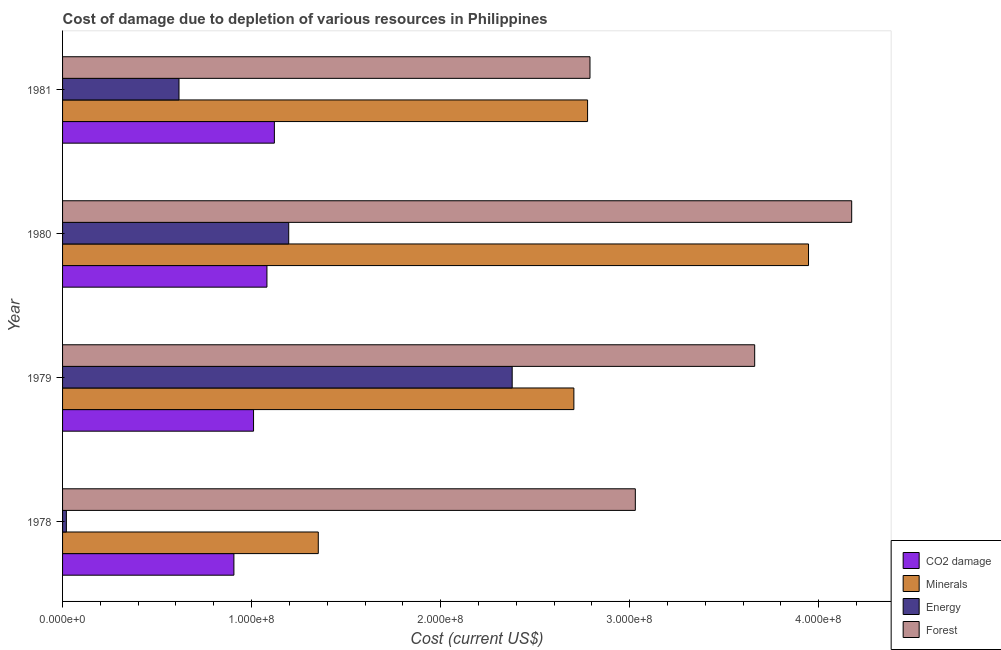How many bars are there on the 3rd tick from the top?
Your answer should be very brief. 4. How many bars are there on the 3rd tick from the bottom?
Provide a succinct answer. 4. What is the label of the 4th group of bars from the top?
Your answer should be compact. 1978. What is the cost of damage due to depletion of minerals in 1981?
Give a very brief answer. 2.78e+08. Across all years, what is the maximum cost of damage due to depletion of coal?
Offer a very short reply. 1.12e+08. Across all years, what is the minimum cost of damage due to depletion of minerals?
Make the answer very short. 1.35e+08. In which year was the cost of damage due to depletion of minerals minimum?
Your response must be concise. 1978. What is the total cost of damage due to depletion of energy in the graph?
Keep it short and to the point. 4.21e+08. What is the difference between the cost of damage due to depletion of minerals in 1980 and that in 1981?
Give a very brief answer. 1.17e+08. What is the difference between the cost of damage due to depletion of coal in 1981 and the cost of damage due to depletion of minerals in 1980?
Provide a short and direct response. -2.83e+08. What is the average cost of damage due to depletion of minerals per year?
Make the answer very short. 2.70e+08. In the year 1978, what is the difference between the cost of damage due to depletion of coal and cost of damage due to depletion of minerals?
Your answer should be very brief. -4.46e+07. What is the ratio of the cost of damage due to depletion of coal in 1979 to that in 1980?
Keep it short and to the point. 0.93. What is the difference between the highest and the second highest cost of damage due to depletion of coal?
Ensure brevity in your answer.  3.93e+06. What is the difference between the highest and the lowest cost of damage due to depletion of forests?
Your answer should be very brief. 1.38e+08. In how many years, is the cost of damage due to depletion of energy greater than the average cost of damage due to depletion of energy taken over all years?
Your response must be concise. 2. What does the 1st bar from the top in 1980 represents?
Make the answer very short. Forest. What does the 1st bar from the bottom in 1979 represents?
Make the answer very short. CO2 damage. Is it the case that in every year, the sum of the cost of damage due to depletion of coal and cost of damage due to depletion of minerals is greater than the cost of damage due to depletion of energy?
Ensure brevity in your answer.  Yes. How many bars are there?
Provide a succinct answer. 16. Are all the bars in the graph horizontal?
Offer a terse response. Yes. Does the graph contain any zero values?
Offer a very short reply. No. How many legend labels are there?
Your answer should be compact. 4. How are the legend labels stacked?
Provide a short and direct response. Vertical. What is the title of the graph?
Provide a succinct answer. Cost of damage due to depletion of various resources in Philippines . What is the label or title of the X-axis?
Your answer should be very brief. Cost (current US$). What is the Cost (current US$) in CO2 damage in 1978?
Your answer should be very brief. 9.06e+07. What is the Cost (current US$) of Minerals in 1978?
Ensure brevity in your answer.  1.35e+08. What is the Cost (current US$) of Energy in 1978?
Provide a short and direct response. 2.02e+06. What is the Cost (current US$) in Forest in 1978?
Provide a succinct answer. 3.03e+08. What is the Cost (current US$) in CO2 damage in 1979?
Make the answer very short. 1.01e+08. What is the Cost (current US$) of Minerals in 1979?
Your answer should be very brief. 2.70e+08. What is the Cost (current US$) of Energy in 1979?
Provide a short and direct response. 2.38e+08. What is the Cost (current US$) of Forest in 1979?
Your response must be concise. 3.66e+08. What is the Cost (current US$) in CO2 damage in 1980?
Ensure brevity in your answer.  1.08e+08. What is the Cost (current US$) in Minerals in 1980?
Your answer should be very brief. 3.95e+08. What is the Cost (current US$) of Energy in 1980?
Offer a terse response. 1.20e+08. What is the Cost (current US$) in Forest in 1980?
Keep it short and to the point. 4.17e+08. What is the Cost (current US$) in CO2 damage in 1981?
Your answer should be very brief. 1.12e+08. What is the Cost (current US$) of Minerals in 1981?
Your response must be concise. 2.78e+08. What is the Cost (current US$) in Energy in 1981?
Provide a short and direct response. 6.16e+07. What is the Cost (current US$) in Forest in 1981?
Ensure brevity in your answer.  2.79e+08. Across all years, what is the maximum Cost (current US$) of CO2 damage?
Give a very brief answer. 1.12e+08. Across all years, what is the maximum Cost (current US$) in Minerals?
Your answer should be very brief. 3.95e+08. Across all years, what is the maximum Cost (current US$) of Energy?
Keep it short and to the point. 2.38e+08. Across all years, what is the maximum Cost (current US$) of Forest?
Ensure brevity in your answer.  4.17e+08. Across all years, what is the minimum Cost (current US$) in CO2 damage?
Offer a very short reply. 9.06e+07. Across all years, what is the minimum Cost (current US$) in Minerals?
Make the answer very short. 1.35e+08. Across all years, what is the minimum Cost (current US$) in Energy?
Make the answer very short. 2.02e+06. Across all years, what is the minimum Cost (current US$) of Forest?
Ensure brevity in your answer.  2.79e+08. What is the total Cost (current US$) of CO2 damage in the graph?
Offer a very short reply. 4.12e+08. What is the total Cost (current US$) in Minerals in the graph?
Provide a succinct answer. 1.08e+09. What is the total Cost (current US$) in Energy in the graph?
Make the answer very short. 4.21e+08. What is the total Cost (current US$) in Forest in the graph?
Give a very brief answer. 1.37e+09. What is the difference between the Cost (current US$) of CO2 damage in 1978 and that in 1979?
Your answer should be very brief. -1.04e+07. What is the difference between the Cost (current US$) of Minerals in 1978 and that in 1979?
Your answer should be very brief. -1.35e+08. What is the difference between the Cost (current US$) of Energy in 1978 and that in 1979?
Offer a very short reply. -2.36e+08. What is the difference between the Cost (current US$) in Forest in 1978 and that in 1979?
Offer a terse response. -6.31e+07. What is the difference between the Cost (current US$) in CO2 damage in 1978 and that in 1980?
Offer a terse response. -1.75e+07. What is the difference between the Cost (current US$) in Minerals in 1978 and that in 1980?
Offer a terse response. -2.59e+08. What is the difference between the Cost (current US$) in Energy in 1978 and that in 1980?
Keep it short and to the point. -1.18e+08. What is the difference between the Cost (current US$) of Forest in 1978 and that in 1980?
Keep it short and to the point. -1.14e+08. What is the difference between the Cost (current US$) in CO2 damage in 1978 and that in 1981?
Your response must be concise. -2.14e+07. What is the difference between the Cost (current US$) of Minerals in 1978 and that in 1981?
Your response must be concise. -1.42e+08. What is the difference between the Cost (current US$) in Energy in 1978 and that in 1981?
Give a very brief answer. -5.96e+07. What is the difference between the Cost (current US$) of Forest in 1978 and that in 1981?
Your answer should be compact. 2.40e+07. What is the difference between the Cost (current US$) of CO2 damage in 1979 and that in 1980?
Offer a terse response. -7.08e+06. What is the difference between the Cost (current US$) in Minerals in 1979 and that in 1980?
Make the answer very short. -1.24e+08. What is the difference between the Cost (current US$) of Energy in 1979 and that in 1980?
Provide a succinct answer. 1.18e+08. What is the difference between the Cost (current US$) of Forest in 1979 and that in 1980?
Offer a terse response. -5.13e+07. What is the difference between the Cost (current US$) in CO2 damage in 1979 and that in 1981?
Give a very brief answer. -1.10e+07. What is the difference between the Cost (current US$) in Minerals in 1979 and that in 1981?
Ensure brevity in your answer.  -7.25e+06. What is the difference between the Cost (current US$) of Energy in 1979 and that in 1981?
Your answer should be compact. 1.76e+08. What is the difference between the Cost (current US$) in Forest in 1979 and that in 1981?
Offer a terse response. 8.71e+07. What is the difference between the Cost (current US$) in CO2 damage in 1980 and that in 1981?
Keep it short and to the point. -3.93e+06. What is the difference between the Cost (current US$) in Minerals in 1980 and that in 1981?
Give a very brief answer. 1.17e+08. What is the difference between the Cost (current US$) in Energy in 1980 and that in 1981?
Your answer should be very brief. 5.80e+07. What is the difference between the Cost (current US$) of Forest in 1980 and that in 1981?
Provide a succinct answer. 1.38e+08. What is the difference between the Cost (current US$) of CO2 damage in 1978 and the Cost (current US$) of Minerals in 1979?
Make the answer very short. -1.80e+08. What is the difference between the Cost (current US$) in CO2 damage in 1978 and the Cost (current US$) in Energy in 1979?
Keep it short and to the point. -1.47e+08. What is the difference between the Cost (current US$) of CO2 damage in 1978 and the Cost (current US$) of Forest in 1979?
Give a very brief answer. -2.75e+08. What is the difference between the Cost (current US$) in Minerals in 1978 and the Cost (current US$) in Energy in 1979?
Your answer should be very brief. -1.03e+08. What is the difference between the Cost (current US$) of Minerals in 1978 and the Cost (current US$) of Forest in 1979?
Provide a succinct answer. -2.31e+08. What is the difference between the Cost (current US$) in Energy in 1978 and the Cost (current US$) in Forest in 1979?
Make the answer very short. -3.64e+08. What is the difference between the Cost (current US$) in CO2 damage in 1978 and the Cost (current US$) in Minerals in 1980?
Make the answer very short. -3.04e+08. What is the difference between the Cost (current US$) in CO2 damage in 1978 and the Cost (current US$) in Energy in 1980?
Provide a short and direct response. -2.90e+07. What is the difference between the Cost (current US$) of CO2 damage in 1978 and the Cost (current US$) of Forest in 1980?
Give a very brief answer. -3.27e+08. What is the difference between the Cost (current US$) of Minerals in 1978 and the Cost (current US$) of Energy in 1980?
Give a very brief answer. 1.56e+07. What is the difference between the Cost (current US$) in Minerals in 1978 and the Cost (current US$) in Forest in 1980?
Provide a succinct answer. -2.82e+08. What is the difference between the Cost (current US$) of Energy in 1978 and the Cost (current US$) of Forest in 1980?
Your answer should be compact. -4.15e+08. What is the difference between the Cost (current US$) in CO2 damage in 1978 and the Cost (current US$) in Minerals in 1981?
Your answer should be compact. -1.87e+08. What is the difference between the Cost (current US$) of CO2 damage in 1978 and the Cost (current US$) of Energy in 1981?
Ensure brevity in your answer.  2.90e+07. What is the difference between the Cost (current US$) in CO2 damage in 1978 and the Cost (current US$) in Forest in 1981?
Offer a terse response. -1.88e+08. What is the difference between the Cost (current US$) in Minerals in 1978 and the Cost (current US$) in Energy in 1981?
Make the answer very short. 7.37e+07. What is the difference between the Cost (current US$) of Minerals in 1978 and the Cost (current US$) of Forest in 1981?
Provide a short and direct response. -1.44e+08. What is the difference between the Cost (current US$) of Energy in 1978 and the Cost (current US$) of Forest in 1981?
Provide a succinct answer. -2.77e+08. What is the difference between the Cost (current US$) in CO2 damage in 1979 and the Cost (current US$) in Minerals in 1980?
Offer a terse response. -2.94e+08. What is the difference between the Cost (current US$) of CO2 damage in 1979 and the Cost (current US$) of Energy in 1980?
Your answer should be compact. -1.86e+07. What is the difference between the Cost (current US$) of CO2 damage in 1979 and the Cost (current US$) of Forest in 1980?
Keep it short and to the point. -3.16e+08. What is the difference between the Cost (current US$) in Minerals in 1979 and the Cost (current US$) in Energy in 1980?
Make the answer very short. 1.51e+08. What is the difference between the Cost (current US$) of Minerals in 1979 and the Cost (current US$) of Forest in 1980?
Offer a terse response. -1.47e+08. What is the difference between the Cost (current US$) in Energy in 1979 and the Cost (current US$) in Forest in 1980?
Your answer should be very brief. -1.80e+08. What is the difference between the Cost (current US$) in CO2 damage in 1979 and the Cost (current US$) in Minerals in 1981?
Provide a succinct answer. -1.77e+08. What is the difference between the Cost (current US$) in CO2 damage in 1979 and the Cost (current US$) in Energy in 1981?
Offer a terse response. 3.94e+07. What is the difference between the Cost (current US$) in CO2 damage in 1979 and the Cost (current US$) in Forest in 1981?
Provide a succinct answer. -1.78e+08. What is the difference between the Cost (current US$) of Minerals in 1979 and the Cost (current US$) of Energy in 1981?
Your answer should be very brief. 2.09e+08. What is the difference between the Cost (current US$) of Minerals in 1979 and the Cost (current US$) of Forest in 1981?
Your answer should be very brief. -8.52e+06. What is the difference between the Cost (current US$) in Energy in 1979 and the Cost (current US$) in Forest in 1981?
Make the answer very short. -4.12e+07. What is the difference between the Cost (current US$) of CO2 damage in 1980 and the Cost (current US$) of Minerals in 1981?
Provide a short and direct response. -1.70e+08. What is the difference between the Cost (current US$) in CO2 damage in 1980 and the Cost (current US$) in Energy in 1981?
Offer a very short reply. 4.65e+07. What is the difference between the Cost (current US$) of CO2 damage in 1980 and the Cost (current US$) of Forest in 1981?
Give a very brief answer. -1.71e+08. What is the difference between the Cost (current US$) of Minerals in 1980 and the Cost (current US$) of Energy in 1981?
Your answer should be compact. 3.33e+08. What is the difference between the Cost (current US$) in Minerals in 1980 and the Cost (current US$) in Forest in 1981?
Offer a very short reply. 1.16e+08. What is the difference between the Cost (current US$) of Energy in 1980 and the Cost (current US$) of Forest in 1981?
Ensure brevity in your answer.  -1.59e+08. What is the average Cost (current US$) of CO2 damage per year?
Ensure brevity in your answer.  1.03e+08. What is the average Cost (current US$) of Minerals per year?
Your answer should be very brief. 2.70e+08. What is the average Cost (current US$) in Energy per year?
Give a very brief answer. 1.05e+08. What is the average Cost (current US$) in Forest per year?
Your answer should be very brief. 3.41e+08. In the year 1978, what is the difference between the Cost (current US$) in CO2 damage and Cost (current US$) in Minerals?
Make the answer very short. -4.46e+07. In the year 1978, what is the difference between the Cost (current US$) of CO2 damage and Cost (current US$) of Energy?
Provide a short and direct response. 8.86e+07. In the year 1978, what is the difference between the Cost (current US$) of CO2 damage and Cost (current US$) of Forest?
Offer a terse response. -2.12e+08. In the year 1978, what is the difference between the Cost (current US$) of Minerals and Cost (current US$) of Energy?
Give a very brief answer. 1.33e+08. In the year 1978, what is the difference between the Cost (current US$) of Minerals and Cost (current US$) of Forest?
Ensure brevity in your answer.  -1.68e+08. In the year 1978, what is the difference between the Cost (current US$) in Energy and Cost (current US$) in Forest?
Ensure brevity in your answer.  -3.01e+08. In the year 1979, what is the difference between the Cost (current US$) of CO2 damage and Cost (current US$) of Minerals?
Your answer should be very brief. -1.69e+08. In the year 1979, what is the difference between the Cost (current US$) of CO2 damage and Cost (current US$) of Energy?
Ensure brevity in your answer.  -1.37e+08. In the year 1979, what is the difference between the Cost (current US$) of CO2 damage and Cost (current US$) of Forest?
Make the answer very short. -2.65e+08. In the year 1979, what is the difference between the Cost (current US$) in Minerals and Cost (current US$) in Energy?
Ensure brevity in your answer.  3.26e+07. In the year 1979, what is the difference between the Cost (current US$) in Minerals and Cost (current US$) in Forest?
Provide a succinct answer. -9.56e+07. In the year 1979, what is the difference between the Cost (current US$) of Energy and Cost (current US$) of Forest?
Your answer should be compact. -1.28e+08. In the year 1980, what is the difference between the Cost (current US$) in CO2 damage and Cost (current US$) in Minerals?
Offer a very short reply. -2.86e+08. In the year 1980, what is the difference between the Cost (current US$) in CO2 damage and Cost (current US$) in Energy?
Ensure brevity in your answer.  -1.15e+07. In the year 1980, what is the difference between the Cost (current US$) of CO2 damage and Cost (current US$) of Forest?
Make the answer very short. -3.09e+08. In the year 1980, what is the difference between the Cost (current US$) of Minerals and Cost (current US$) of Energy?
Ensure brevity in your answer.  2.75e+08. In the year 1980, what is the difference between the Cost (current US$) in Minerals and Cost (current US$) in Forest?
Your response must be concise. -2.28e+07. In the year 1980, what is the difference between the Cost (current US$) in Energy and Cost (current US$) in Forest?
Provide a short and direct response. -2.98e+08. In the year 1981, what is the difference between the Cost (current US$) of CO2 damage and Cost (current US$) of Minerals?
Keep it short and to the point. -1.66e+08. In the year 1981, what is the difference between the Cost (current US$) of CO2 damage and Cost (current US$) of Energy?
Provide a succinct answer. 5.04e+07. In the year 1981, what is the difference between the Cost (current US$) in CO2 damage and Cost (current US$) in Forest?
Make the answer very short. -1.67e+08. In the year 1981, what is the difference between the Cost (current US$) in Minerals and Cost (current US$) in Energy?
Make the answer very short. 2.16e+08. In the year 1981, what is the difference between the Cost (current US$) in Minerals and Cost (current US$) in Forest?
Your answer should be very brief. -1.27e+06. In the year 1981, what is the difference between the Cost (current US$) of Energy and Cost (current US$) of Forest?
Keep it short and to the point. -2.17e+08. What is the ratio of the Cost (current US$) of CO2 damage in 1978 to that in 1979?
Ensure brevity in your answer.  0.9. What is the ratio of the Cost (current US$) of Minerals in 1978 to that in 1979?
Your response must be concise. 0.5. What is the ratio of the Cost (current US$) in Energy in 1978 to that in 1979?
Your answer should be very brief. 0.01. What is the ratio of the Cost (current US$) of Forest in 1978 to that in 1979?
Provide a succinct answer. 0.83. What is the ratio of the Cost (current US$) of CO2 damage in 1978 to that in 1980?
Make the answer very short. 0.84. What is the ratio of the Cost (current US$) in Minerals in 1978 to that in 1980?
Your response must be concise. 0.34. What is the ratio of the Cost (current US$) of Energy in 1978 to that in 1980?
Make the answer very short. 0.02. What is the ratio of the Cost (current US$) of Forest in 1978 to that in 1980?
Ensure brevity in your answer.  0.73. What is the ratio of the Cost (current US$) in CO2 damage in 1978 to that in 1981?
Offer a very short reply. 0.81. What is the ratio of the Cost (current US$) of Minerals in 1978 to that in 1981?
Give a very brief answer. 0.49. What is the ratio of the Cost (current US$) in Energy in 1978 to that in 1981?
Give a very brief answer. 0.03. What is the ratio of the Cost (current US$) of Forest in 1978 to that in 1981?
Provide a short and direct response. 1.09. What is the ratio of the Cost (current US$) of CO2 damage in 1979 to that in 1980?
Offer a very short reply. 0.93. What is the ratio of the Cost (current US$) of Minerals in 1979 to that in 1980?
Make the answer very short. 0.69. What is the ratio of the Cost (current US$) in Energy in 1979 to that in 1980?
Keep it short and to the point. 1.99. What is the ratio of the Cost (current US$) in Forest in 1979 to that in 1980?
Make the answer very short. 0.88. What is the ratio of the Cost (current US$) of CO2 damage in 1979 to that in 1981?
Provide a short and direct response. 0.9. What is the ratio of the Cost (current US$) of Minerals in 1979 to that in 1981?
Your answer should be compact. 0.97. What is the ratio of the Cost (current US$) of Energy in 1979 to that in 1981?
Your answer should be compact. 3.86. What is the ratio of the Cost (current US$) of Forest in 1979 to that in 1981?
Ensure brevity in your answer.  1.31. What is the ratio of the Cost (current US$) in CO2 damage in 1980 to that in 1981?
Your response must be concise. 0.96. What is the ratio of the Cost (current US$) of Minerals in 1980 to that in 1981?
Provide a short and direct response. 1.42. What is the ratio of the Cost (current US$) of Energy in 1980 to that in 1981?
Ensure brevity in your answer.  1.94. What is the ratio of the Cost (current US$) of Forest in 1980 to that in 1981?
Your answer should be compact. 1.5. What is the difference between the highest and the second highest Cost (current US$) in CO2 damage?
Your answer should be compact. 3.93e+06. What is the difference between the highest and the second highest Cost (current US$) of Minerals?
Provide a succinct answer. 1.17e+08. What is the difference between the highest and the second highest Cost (current US$) of Energy?
Provide a succinct answer. 1.18e+08. What is the difference between the highest and the second highest Cost (current US$) of Forest?
Your response must be concise. 5.13e+07. What is the difference between the highest and the lowest Cost (current US$) in CO2 damage?
Keep it short and to the point. 2.14e+07. What is the difference between the highest and the lowest Cost (current US$) of Minerals?
Your answer should be very brief. 2.59e+08. What is the difference between the highest and the lowest Cost (current US$) in Energy?
Offer a very short reply. 2.36e+08. What is the difference between the highest and the lowest Cost (current US$) of Forest?
Keep it short and to the point. 1.38e+08. 